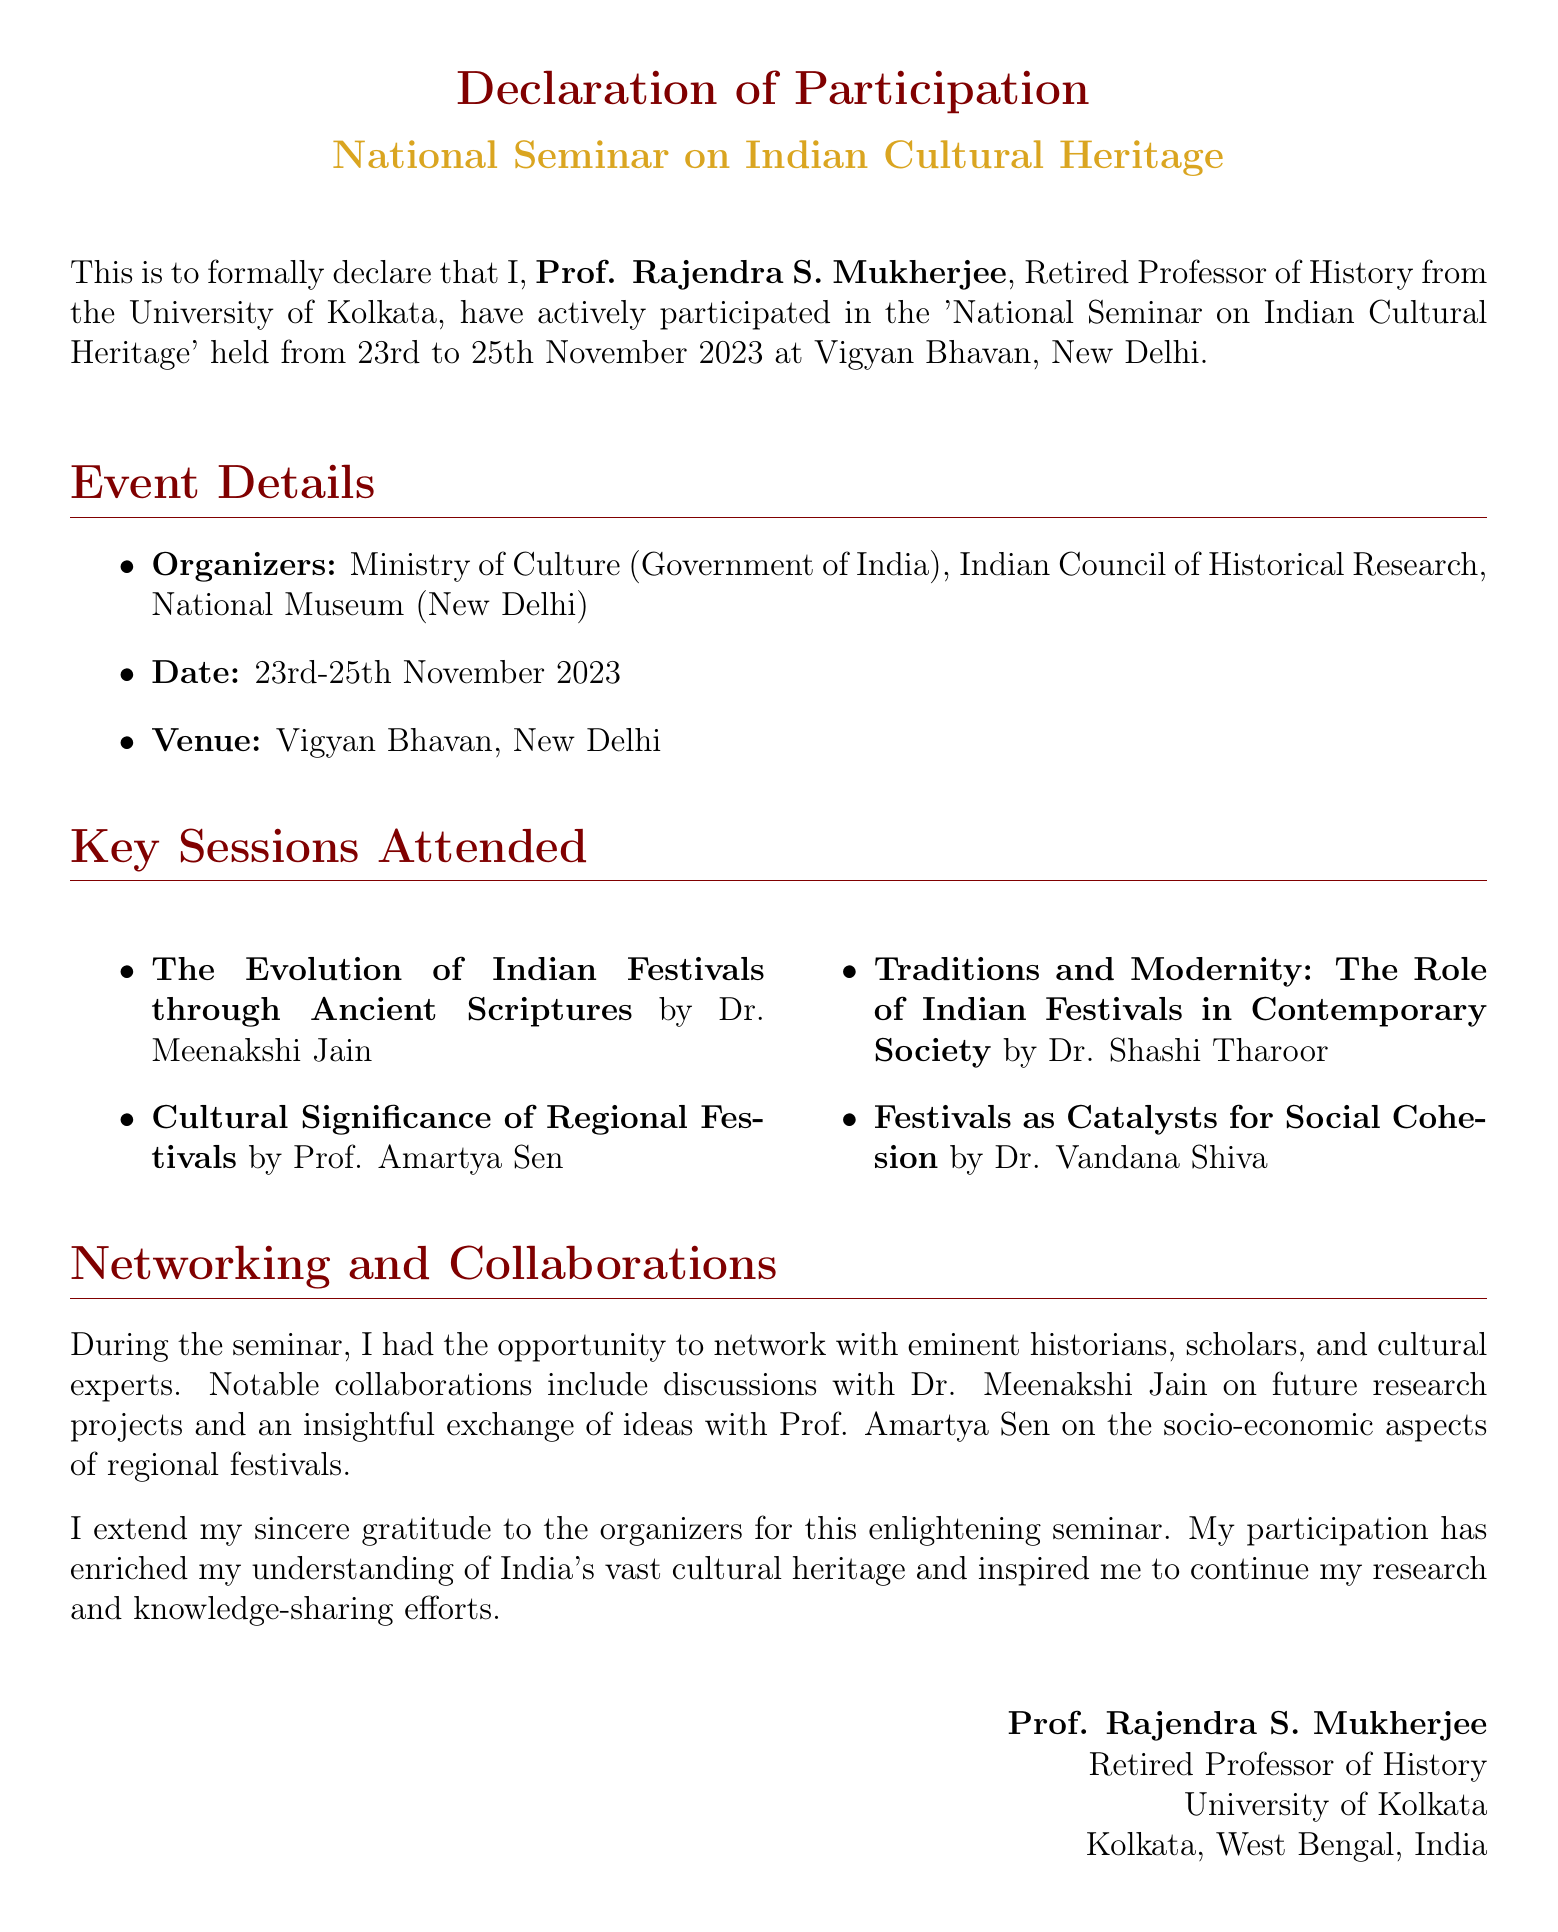what is the name of the participant? The participant's name is mentioned in the declaration as Prof. Rajendra S. Mukherjee.
Answer: Prof. Rajendra S. Mukherjee what is the venue of the seminar? The venue of the seminar is specified in the document as Vigyan Bhavan, New Delhi.
Answer: Vigyan Bhavan, New Delhi who organized the seminar? The organizers of the seminar are listed in the document as the Ministry of Culture (Government of India), Indian Council of Historical Research, and National Museum (New Delhi).
Answer: Ministry of Culture (Government of India), Indian Council of Historical Research, National Museum (New Delhi) when was the seminar held? The document states that the seminar took place from 23rd to 25th November 2023.
Answer: 23rd to 25th November 2023 which session was conducted by Dr. Shashi Tharoor? The session conducted by Dr. Shashi Tharoor is mentioned as "Traditions and Modernity: The Role of Indian Festivals in Contemporary Society."
Answer: Traditions and Modernity: The Role of Indian Festivals in Contemporary Society what was a key theme discussed by Prof. Amartya Sen? The key theme discussed by Prof. Amartya Sen was the cultural significance of regional festivals.
Answer: Cultural Significance of Regional Festivals how did the participant feel about the seminar? The participant expresses gratitude for the enlightening seminar and notes that it enriched their understanding of India's cultural heritage.
Answer: Enriched understanding of India's cultural heritage what type of experts did the participant network with? The document mentions that the participant networked with eminent historians, scholars, and cultural experts.
Answer: Historians, scholars, and cultural experts 